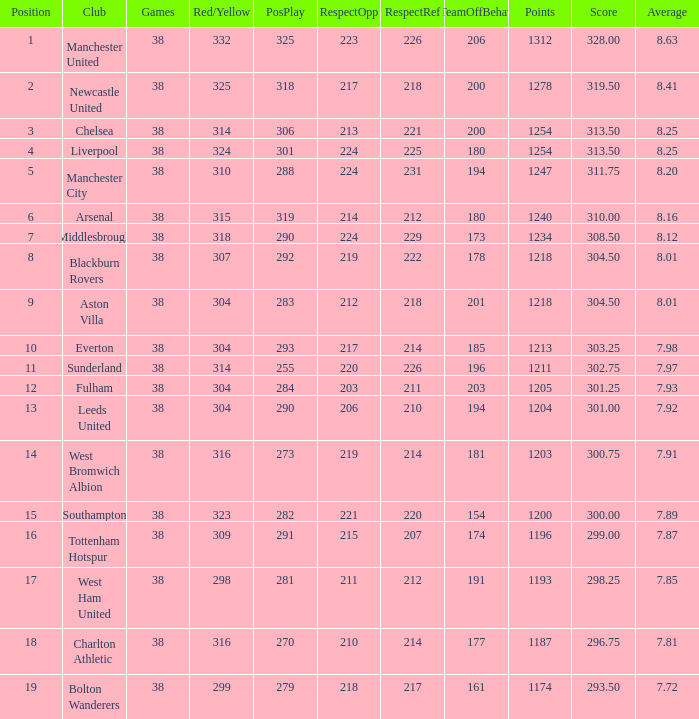Name the most red/yellow cards for positive play being 255 314.0. 